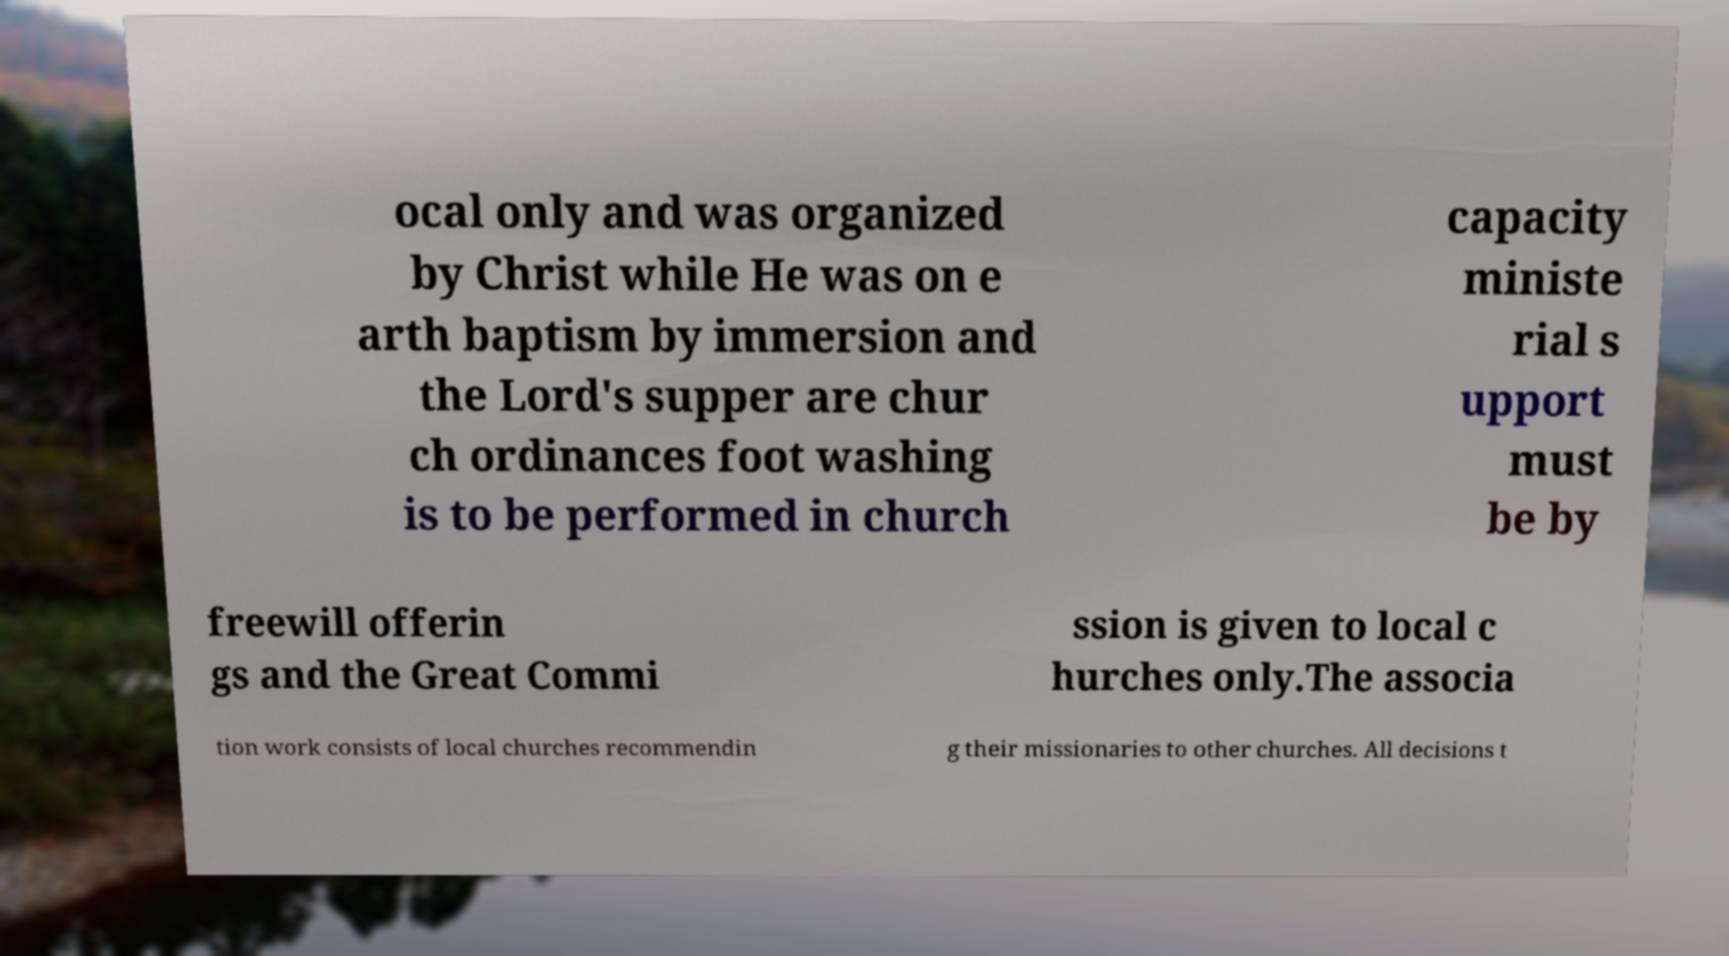I need the written content from this picture converted into text. Can you do that? ocal only and was organized by Christ while He was on e arth baptism by immersion and the Lord's supper are chur ch ordinances foot washing is to be performed in church capacity ministe rial s upport must be by freewill offerin gs and the Great Commi ssion is given to local c hurches only.The associa tion work consists of local churches recommendin g their missionaries to other churches. All decisions t 